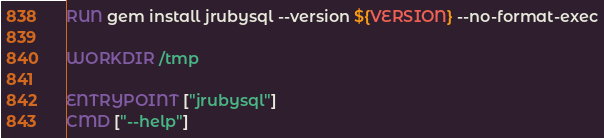Convert code to text. <code><loc_0><loc_0><loc_500><loc_500><_Dockerfile_>RUN gem install jrubysql --version ${VERSION} --no-format-exec

WORKDIR /tmp

ENTRYPOINT ["jrubysql"]
CMD ["--help"]
</code> 